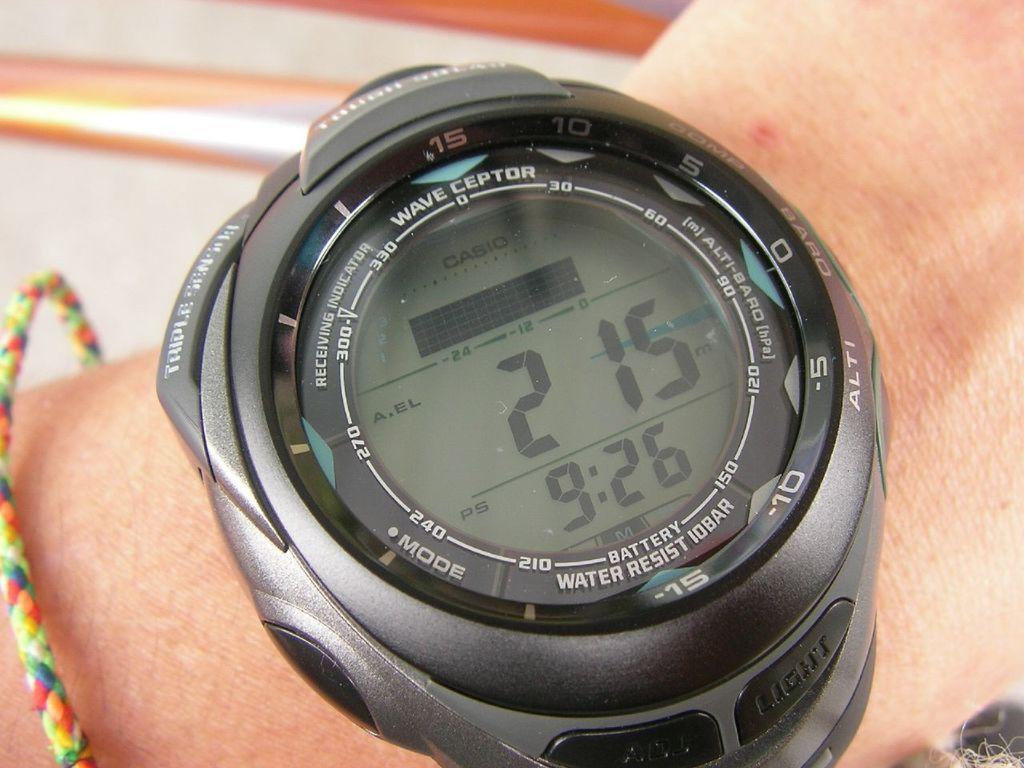Describe this image in one or two sentences. Here I can see a black color watch to a person's hand. Along with the watch I can see a band which is in multiple colors. In this watch I can see a glass and around the glass I can see some text and numbers. The background is blurred. 